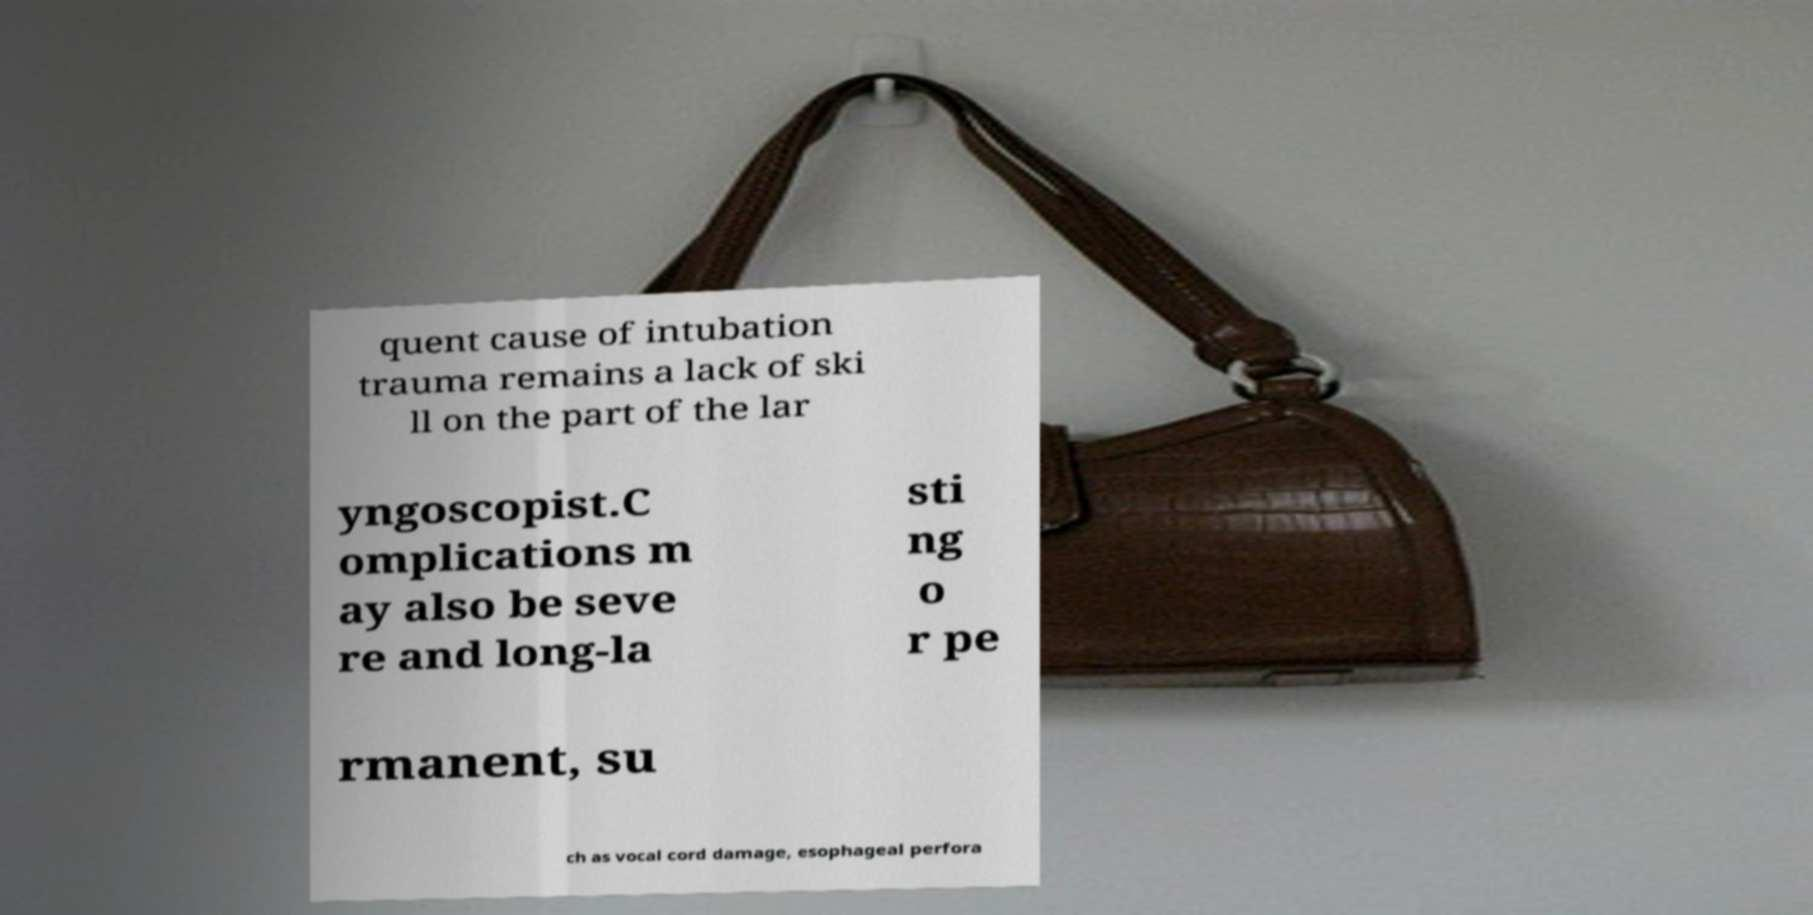Please identify and transcribe the text found in this image. quent cause of intubation trauma remains a lack of ski ll on the part of the lar yngoscopist.C omplications m ay also be seve re and long-la sti ng o r pe rmanent, su ch as vocal cord damage, esophageal perfora 